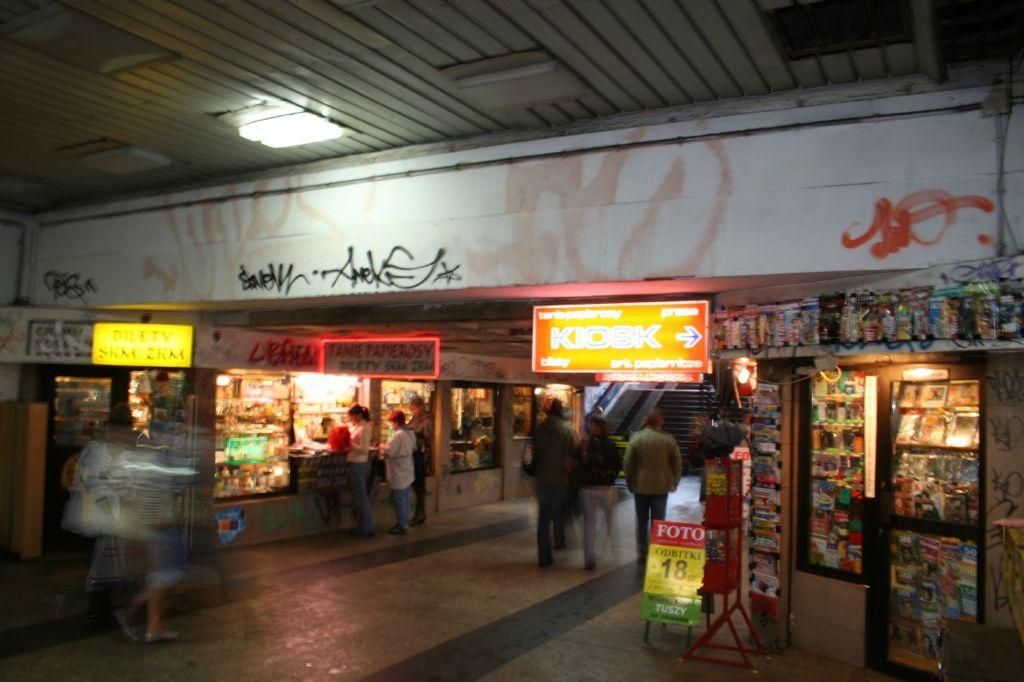<image>
Give a short and clear explanation of the subsequent image. A foreign shoping center with a large yellow sign reading "KIOSK" that points to the right. 